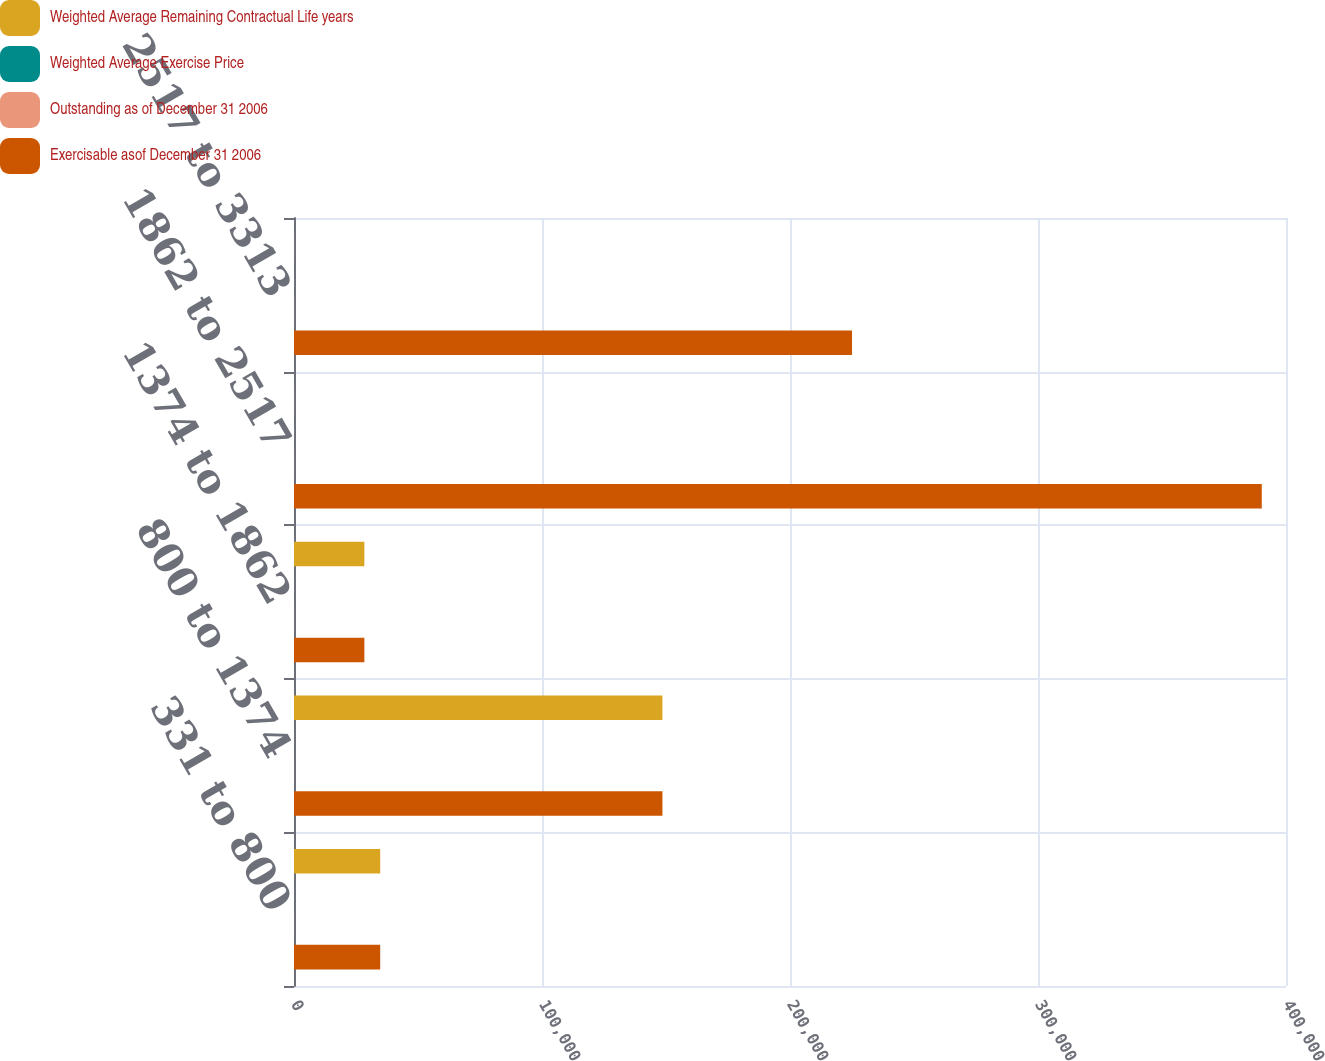Convert chart to OTSL. <chart><loc_0><loc_0><loc_500><loc_500><stacked_bar_chart><ecel><fcel>331 to 800<fcel>800 to 1374<fcel>1374 to 1862<fcel>1862 to 2517<fcel>2517 to 3313<nl><fcel>Weighted Average Remaining Contractual Life years<fcel>34757<fcel>148556<fcel>28374<fcel>26.335<fcel>26.335<nl><fcel>Weighted Average Exercise Price<fcel>3.6<fcel>3.9<fcel>3.5<fcel>7<fcel>8.7<nl><fcel>Outstanding as of December 31 2006<fcel>5.26<fcel>12.31<fcel>15.84<fcel>23.62<fcel>29.05<nl><fcel>Exercisable asof December 31 2006<fcel>34757<fcel>148556<fcel>28374<fcel>390230<fcel>225008<nl></chart> 